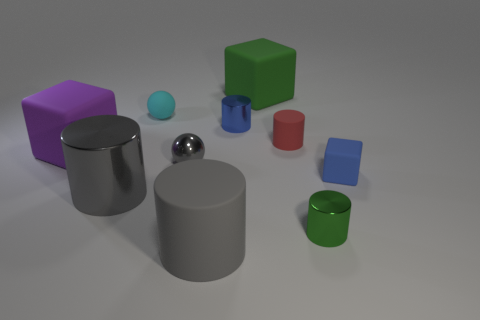Subtract 1 cylinders. How many cylinders are left? 4 Subtract all purple blocks. Subtract all yellow spheres. How many blocks are left? 2 Subtract all spheres. How many objects are left? 8 Subtract 0 purple balls. How many objects are left? 10 Subtract all purple cylinders. Subtract all tiny gray metal objects. How many objects are left? 9 Add 4 purple blocks. How many purple blocks are left? 5 Add 9 tiny blue cubes. How many tiny blue cubes exist? 10 